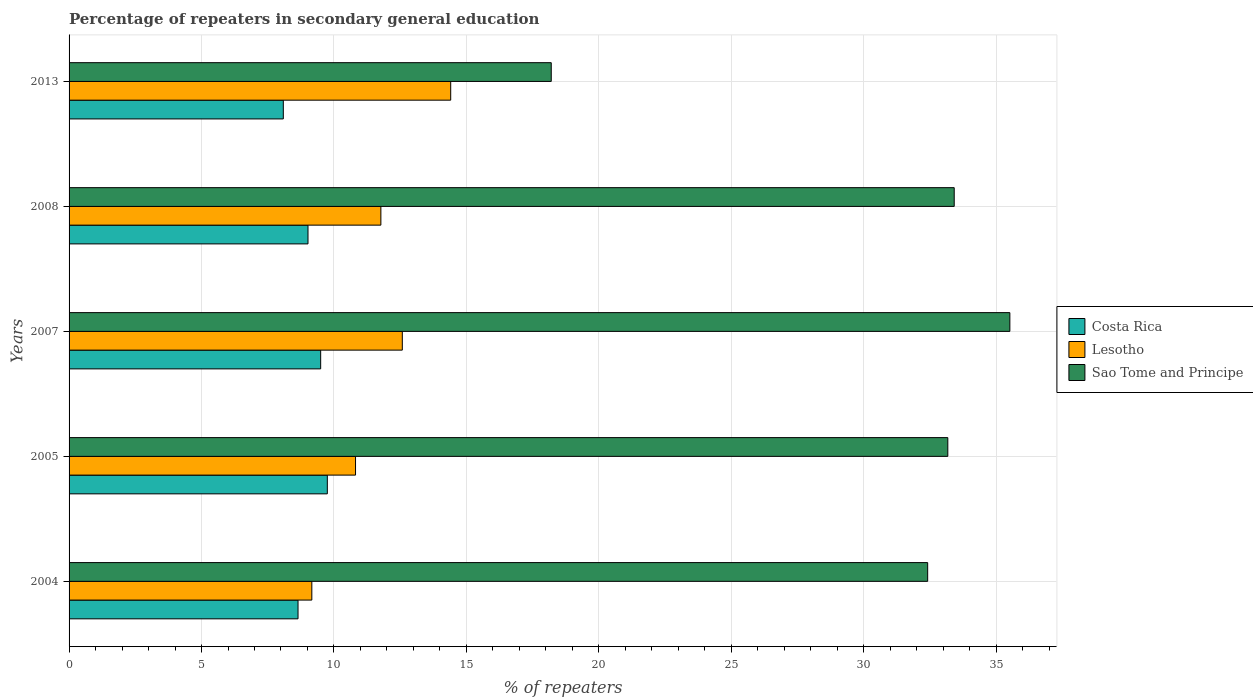How many different coloured bars are there?
Give a very brief answer. 3. How many bars are there on the 2nd tick from the top?
Your answer should be compact. 3. How many bars are there on the 2nd tick from the bottom?
Provide a short and direct response. 3. What is the percentage of repeaters in secondary general education in Costa Rica in 2004?
Offer a terse response. 8.64. Across all years, what is the maximum percentage of repeaters in secondary general education in Costa Rica?
Keep it short and to the point. 9.75. Across all years, what is the minimum percentage of repeaters in secondary general education in Costa Rica?
Make the answer very short. 8.09. In which year was the percentage of repeaters in secondary general education in Costa Rica minimum?
Ensure brevity in your answer.  2013. What is the total percentage of repeaters in secondary general education in Costa Rica in the graph?
Make the answer very short. 45. What is the difference between the percentage of repeaters in secondary general education in Sao Tome and Principe in 2005 and that in 2008?
Your answer should be compact. -0.24. What is the difference between the percentage of repeaters in secondary general education in Lesotho in 2013 and the percentage of repeaters in secondary general education in Sao Tome and Principe in 2007?
Your response must be concise. -21.11. What is the average percentage of repeaters in secondary general education in Sao Tome and Principe per year?
Keep it short and to the point. 30.55. In the year 2007, what is the difference between the percentage of repeaters in secondary general education in Sao Tome and Principe and percentage of repeaters in secondary general education in Costa Rica?
Offer a terse response. 26.02. In how many years, is the percentage of repeaters in secondary general education in Sao Tome and Principe greater than 16 %?
Provide a succinct answer. 5. What is the ratio of the percentage of repeaters in secondary general education in Sao Tome and Principe in 2004 to that in 2005?
Keep it short and to the point. 0.98. What is the difference between the highest and the second highest percentage of repeaters in secondary general education in Sao Tome and Principe?
Offer a terse response. 2.1. What is the difference between the highest and the lowest percentage of repeaters in secondary general education in Lesotho?
Your response must be concise. 5.24. What does the 1st bar from the top in 2013 represents?
Keep it short and to the point. Sao Tome and Principe. What does the 1st bar from the bottom in 2007 represents?
Keep it short and to the point. Costa Rica. Is it the case that in every year, the sum of the percentage of repeaters in secondary general education in Costa Rica and percentage of repeaters in secondary general education in Sao Tome and Principe is greater than the percentage of repeaters in secondary general education in Lesotho?
Ensure brevity in your answer.  Yes. Are all the bars in the graph horizontal?
Your answer should be compact. Yes. What is the difference between two consecutive major ticks on the X-axis?
Provide a short and direct response. 5. Are the values on the major ticks of X-axis written in scientific E-notation?
Offer a terse response. No. Does the graph contain grids?
Give a very brief answer. Yes. Where does the legend appear in the graph?
Your answer should be compact. Center right. How are the legend labels stacked?
Ensure brevity in your answer.  Vertical. What is the title of the graph?
Your answer should be very brief. Percentage of repeaters in secondary general education. Does "Djibouti" appear as one of the legend labels in the graph?
Offer a very short reply. No. What is the label or title of the X-axis?
Your answer should be compact. % of repeaters. What is the % of repeaters of Costa Rica in 2004?
Offer a terse response. 8.64. What is the % of repeaters in Lesotho in 2004?
Your answer should be compact. 9.16. What is the % of repeaters in Sao Tome and Principe in 2004?
Ensure brevity in your answer.  32.41. What is the % of repeaters of Costa Rica in 2005?
Offer a very short reply. 9.75. What is the % of repeaters of Lesotho in 2005?
Provide a short and direct response. 10.81. What is the % of repeaters of Sao Tome and Principe in 2005?
Provide a succinct answer. 33.18. What is the % of repeaters of Costa Rica in 2007?
Provide a short and direct response. 9.5. What is the % of repeaters in Lesotho in 2007?
Offer a terse response. 12.58. What is the % of repeaters of Sao Tome and Principe in 2007?
Make the answer very short. 35.52. What is the % of repeaters in Costa Rica in 2008?
Ensure brevity in your answer.  9.02. What is the % of repeaters in Lesotho in 2008?
Offer a very short reply. 11.77. What is the % of repeaters of Sao Tome and Principe in 2008?
Your answer should be very brief. 33.42. What is the % of repeaters in Costa Rica in 2013?
Provide a short and direct response. 8.09. What is the % of repeaters in Lesotho in 2013?
Give a very brief answer. 14.41. What is the % of repeaters of Sao Tome and Principe in 2013?
Provide a succinct answer. 18.2. Across all years, what is the maximum % of repeaters of Costa Rica?
Offer a very short reply. 9.75. Across all years, what is the maximum % of repeaters in Lesotho?
Ensure brevity in your answer.  14.41. Across all years, what is the maximum % of repeaters in Sao Tome and Principe?
Provide a succinct answer. 35.52. Across all years, what is the minimum % of repeaters in Costa Rica?
Provide a succinct answer. 8.09. Across all years, what is the minimum % of repeaters of Lesotho?
Ensure brevity in your answer.  9.16. Across all years, what is the minimum % of repeaters of Sao Tome and Principe?
Ensure brevity in your answer.  18.2. What is the total % of repeaters of Costa Rica in the graph?
Provide a succinct answer. 45. What is the total % of repeaters of Lesotho in the graph?
Your answer should be very brief. 58.74. What is the total % of repeaters of Sao Tome and Principe in the graph?
Your answer should be compact. 152.73. What is the difference between the % of repeaters of Costa Rica in 2004 and that in 2005?
Provide a succinct answer. -1.11. What is the difference between the % of repeaters in Lesotho in 2004 and that in 2005?
Make the answer very short. -1.65. What is the difference between the % of repeaters in Sao Tome and Principe in 2004 and that in 2005?
Your answer should be compact. -0.76. What is the difference between the % of repeaters of Costa Rica in 2004 and that in 2007?
Provide a short and direct response. -0.85. What is the difference between the % of repeaters of Lesotho in 2004 and that in 2007?
Offer a terse response. -3.42. What is the difference between the % of repeaters of Sao Tome and Principe in 2004 and that in 2007?
Your answer should be very brief. -3.1. What is the difference between the % of repeaters of Costa Rica in 2004 and that in 2008?
Your response must be concise. -0.38. What is the difference between the % of repeaters of Lesotho in 2004 and that in 2008?
Provide a short and direct response. -2.61. What is the difference between the % of repeaters in Sao Tome and Principe in 2004 and that in 2008?
Your response must be concise. -1. What is the difference between the % of repeaters of Costa Rica in 2004 and that in 2013?
Ensure brevity in your answer.  0.56. What is the difference between the % of repeaters of Lesotho in 2004 and that in 2013?
Your answer should be very brief. -5.24. What is the difference between the % of repeaters in Sao Tome and Principe in 2004 and that in 2013?
Your response must be concise. 14.21. What is the difference between the % of repeaters of Costa Rica in 2005 and that in 2007?
Give a very brief answer. 0.25. What is the difference between the % of repeaters of Lesotho in 2005 and that in 2007?
Ensure brevity in your answer.  -1.77. What is the difference between the % of repeaters of Sao Tome and Principe in 2005 and that in 2007?
Ensure brevity in your answer.  -2.34. What is the difference between the % of repeaters of Costa Rica in 2005 and that in 2008?
Your answer should be compact. 0.73. What is the difference between the % of repeaters of Lesotho in 2005 and that in 2008?
Your answer should be very brief. -0.96. What is the difference between the % of repeaters in Sao Tome and Principe in 2005 and that in 2008?
Provide a short and direct response. -0.24. What is the difference between the % of repeaters of Costa Rica in 2005 and that in 2013?
Make the answer very short. 1.66. What is the difference between the % of repeaters of Lesotho in 2005 and that in 2013?
Make the answer very short. -3.59. What is the difference between the % of repeaters of Sao Tome and Principe in 2005 and that in 2013?
Provide a short and direct response. 14.97. What is the difference between the % of repeaters in Costa Rica in 2007 and that in 2008?
Make the answer very short. 0.48. What is the difference between the % of repeaters in Lesotho in 2007 and that in 2008?
Make the answer very short. 0.81. What is the difference between the % of repeaters of Sao Tome and Principe in 2007 and that in 2008?
Provide a short and direct response. 2.1. What is the difference between the % of repeaters in Costa Rica in 2007 and that in 2013?
Make the answer very short. 1.41. What is the difference between the % of repeaters of Lesotho in 2007 and that in 2013?
Keep it short and to the point. -1.83. What is the difference between the % of repeaters of Sao Tome and Principe in 2007 and that in 2013?
Your answer should be compact. 17.31. What is the difference between the % of repeaters in Costa Rica in 2008 and that in 2013?
Offer a terse response. 0.93. What is the difference between the % of repeaters in Lesotho in 2008 and that in 2013?
Make the answer very short. -2.64. What is the difference between the % of repeaters in Sao Tome and Principe in 2008 and that in 2013?
Ensure brevity in your answer.  15.21. What is the difference between the % of repeaters in Costa Rica in 2004 and the % of repeaters in Lesotho in 2005?
Offer a terse response. -2.17. What is the difference between the % of repeaters in Costa Rica in 2004 and the % of repeaters in Sao Tome and Principe in 2005?
Ensure brevity in your answer.  -24.53. What is the difference between the % of repeaters in Lesotho in 2004 and the % of repeaters in Sao Tome and Principe in 2005?
Offer a terse response. -24.01. What is the difference between the % of repeaters in Costa Rica in 2004 and the % of repeaters in Lesotho in 2007?
Your answer should be very brief. -3.94. What is the difference between the % of repeaters in Costa Rica in 2004 and the % of repeaters in Sao Tome and Principe in 2007?
Your answer should be very brief. -26.87. What is the difference between the % of repeaters in Lesotho in 2004 and the % of repeaters in Sao Tome and Principe in 2007?
Provide a succinct answer. -26.35. What is the difference between the % of repeaters of Costa Rica in 2004 and the % of repeaters of Lesotho in 2008?
Your answer should be compact. -3.13. What is the difference between the % of repeaters of Costa Rica in 2004 and the % of repeaters of Sao Tome and Principe in 2008?
Offer a terse response. -24.77. What is the difference between the % of repeaters in Lesotho in 2004 and the % of repeaters in Sao Tome and Principe in 2008?
Give a very brief answer. -24.25. What is the difference between the % of repeaters in Costa Rica in 2004 and the % of repeaters in Lesotho in 2013?
Keep it short and to the point. -5.76. What is the difference between the % of repeaters in Costa Rica in 2004 and the % of repeaters in Sao Tome and Principe in 2013?
Keep it short and to the point. -9.56. What is the difference between the % of repeaters in Lesotho in 2004 and the % of repeaters in Sao Tome and Principe in 2013?
Give a very brief answer. -9.04. What is the difference between the % of repeaters of Costa Rica in 2005 and the % of repeaters of Lesotho in 2007?
Offer a terse response. -2.83. What is the difference between the % of repeaters of Costa Rica in 2005 and the % of repeaters of Sao Tome and Principe in 2007?
Make the answer very short. -25.77. What is the difference between the % of repeaters in Lesotho in 2005 and the % of repeaters in Sao Tome and Principe in 2007?
Give a very brief answer. -24.7. What is the difference between the % of repeaters of Costa Rica in 2005 and the % of repeaters of Lesotho in 2008?
Ensure brevity in your answer.  -2.02. What is the difference between the % of repeaters in Costa Rica in 2005 and the % of repeaters in Sao Tome and Principe in 2008?
Make the answer very short. -23.67. What is the difference between the % of repeaters of Lesotho in 2005 and the % of repeaters of Sao Tome and Principe in 2008?
Keep it short and to the point. -22.6. What is the difference between the % of repeaters in Costa Rica in 2005 and the % of repeaters in Lesotho in 2013?
Provide a succinct answer. -4.66. What is the difference between the % of repeaters in Costa Rica in 2005 and the % of repeaters in Sao Tome and Principe in 2013?
Provide a succinct answer. -8.45. What is the difference between the % of repeaters of Lesotho in 2005 and the % of repeaters of Sao Tome and Principe in 2013?
Provide a succinct answer. -7.39. What is the difference between the % of repeaters in Costa Rica in 2007 and the % of repeaters in Lesotho in 2008?
Provide a short and direct response. -2.27. What is the difference between the % of repeaters in Costa Rica in 2007 and the % of repeaters in Sao Tome and Principe in 2008?
Your response must be concise. -23.92. What is the difference between the % of repeaters in Lesotho in 2007 and the % of repeaters in Sao Tome and Principe in 2008?
Make the answer very short. -20.84. What is the difference between the % of repeaters of Costa Rica in 2007 and the % of repeaters of Lesotho in 2013?
Keep it short and to the point. -4.91. What is the difference between the % of repeaters in Costa Rica in 2007 and the % of repeaters in Sao Tome and Principe in 2013?
Make the answer very short. -8.7. What is the difference between the % of repeaters in Lesotho in 2007 and the % of repeaters in Sao Tome and Principe in 2013?
Offer a very short reply. -5.62. What is the difference between the % of repeaters in Costa Rica in 2008 and the % of repeaters in Lesotho in 2013?
Give a very brief answer. -5.39. What is the difference between the % of repeaters of Costa Rica in 2008 and the % of repeaters of Sao Tome and Principe in 2013?
Ensure brevity in your answer.  -9.18. What is the difference between the % of repeaters in Lesotho in 2008 and the % of repeaters in Sao Tome and Principe in 2013?
Provide a succinct answer. -6.43. What is the average % of repeaters in Costa Rica per year?
Your answer should be compact. 9. What is the average % of repeaters of Lesotho per year?
Your response must be concise. 11.75. What is the average % of repeaters in Sao Tome and Principe per year?
Your answer should be very brief. 30.55. In the year 2004, what is the difference between the % of repeaters of Costa Rica and % of repeaters of Lesotho?
Give a very brief answer. -0.52. In the year 2004, what is the difference between the % of repeaters in Costa Rica and % of repeaters in Sao Tome and Principe?
Offer a very short reply. -23.77. In the year 2004, what is the difference between the % of repeaters of Lesotho and % of repeaters of Sao Tome and Principe?
Ensure brevity in your answer.  -23.25. In the year 2005, what is the difference between the % of repeaters of Costa Rica and % of repeaters of Lesotho?
Your answer should be compact. -1.06. In the year 2005, what is the difference between the % of repeaters of Costa Rica and % of repeaters of Sao Tome and Principe?
Your answer should be very brief. -23.43. In the year 2005, what is the difference between the % of repeaters of Lesotho and % of repeaters of Sao Tome and Principe?
Give a very brief answer. -22.36. In the year 2007, what is the difference between the % of repeaters of Costa Rica and % of repeaters of Lesotho?
Offer a very short reply. -3.08. In the year 2007, what is the difference between the % of repeaters in Costa Rica and % of repeaters in Sao Tome and Principe?
Your answer should be very brief. -26.02. In the year 2007, what is the difference between the % of repeaters of Lesotho and % of repeaters of Sao Tome and Principe?
Offer a terse response. -22.94. In the year 2008, what is the difference between the % of repeaters in Costa Rica and % of repeaters in Lesotho?
Keep it short and to the point. -2.75. In the year 2008, what is the difference between the % of repeaters of Costa Rica and % of repeaters of Sao Tome and Principe?
Your answer should be compact. -24.4. In the year 2008, what is the difference between the % of repeaters of Lesotho and % of repeaters of Sao Tome and Principe?
Your answer should be very brief. -21.65. In the year 2013, what is the difference between the % of repeaters in Costa Rica and % of repeaters in Lesotho?
Offer a terse response. -6.32. In the year 2013, what is the difference between the % of repeaters of Costa Rica and % of repeaters of Sao Tome and Principe?
Your answer should be compact. -10.12. In the year 2013, what is the difference between the % of repeaters of Lesotho and % of repeaters of Sao Tome and Principe?
Offer a very short reply. -3.8. What is the ratio of the % of repeaters of Costa Rica in 2004 to that in 2005?
Give a very brief answer. 0.89. What is the ratio of the % of repeaters in Lesotho in 2004 to that in 2005?
Your answer should be very brief. 0.85. What is the ratio of the % of repeaters of Sao Tome and Principe in 2004 to that in 2005?
Provide a short and direct response. 0.98. What is the ratio of the % of repeaters of Costa Rica in 2004 to that in 2007?
Make the answer very short. 0.91. What is the ratio of the % of repeaters in Lesotho in 2004 to that in 2007?
Make the answer very short. 0.73. What is the ratio of the % of repeaters of Sao Tome and Principe in 2004 to that in 2007?
Keep it short and to the point. 0.91. What is the ratio of the % of repeaters in Lesotho in 2004 to that in 2008?
Your response must be concise. 0.78. What is the ratio of the % of repeaters in Sao Tome and Principe in 2004 to that in 2008?
Your answer should be very brief. 0.97. What is the ratio of the % of repeaters of Costa Rica in 2004 to that in 2013?
Your response must be concise. 1.07. What is the ratio of the % of repeaters in Lesotho in 2004 to that in 2013?
Offer a terse response. 0.64. What is the ratio of the % of repeaters of Sao Tome and Principe in 2004 to that in 2013?
Ensure brevity in your answer.  1.78. What is the ratio of the % of repeaters in Costa Rica in 2005 to that in 2007?
Your response must be concise. 1.03. What is the ratio of the % of repeaters in Lesotho in 2005 to that in 2007?
Provide a succinct answer. 0.86. What is the ratio of the % of repeaters of Sao Tome and Principe in 2005 to that in 2007?
Your answer should be very brief. 0.93. What is the ratio of the % of repeaters of Costa Rica in 2005 to that in 2008?
Ensure brevity in your answer.  1.08. What is the ratio of the % of repeaters of Lesotho in 2005 to that in 2008?
Your answer should be compact. 0.92. What is the ratio of the % of repeaters in Sao Tome and Principe in 2005 to that in 2008?
Give a very brief answer. 0.99. What is the ratio of the % of repeaters in Costa Rica in 2005 to that in 2013?
Provide a short and direct response. 1.21. What is the ratio of the % of repeaters of Lesotho in 2005 to that in 2013?
Offer a terse response. 0.75. What is the ratio of the % of repeaters of Sao Tome and Principe in 2005 to that in 2013?
Offer a terse response. 1.82. What is the ratio of the % of repeaters of Costa Rica in 2007 to that in 2008?
Ensure brevity in your answer.  1.05. What is the ratio of the % of repeaters of Lesotho in 2007 to that in 2008?
Your answer should be compact. 1.07. What is the ratio of the % of repeaters in Sao Tome and Principe in 2007 to that in 2008?
Provide a short and direct response. 1.06. What is the ratio of the % of repeaters of Costa Rica in 2007 to that in 2013?
Your response must be concise. 1.17. What is the ratio of the % of repeaters of Lesotho in 2007 to that in 2013?
Keep it short and to the point. 0.87. What is the ratio of the % of repeaters of Sao Tome and Principe in 2007 to that in 2013?
Offer a terse response. 1.95. What is the ratio of the % of repeaters in Costa Rica in 2008 to that in 2013?
Your answer should be very brief. 1.12. What is the ratio of the % of repeaters in Lesotho in 2008 to that in 2013?
Your answer should be very brief. 0.82. What is the ratio of the % of repeaters of Sao Tome and Principe in 2008 to that in 2013?
Keep it short and to the point. 1.84. What is the difference between the highest and the second highest % of repeaters in Costa Rica?
Provide a short and direct response. 0.25. What is the difference between the highest and the second highest % of repeaters of Lesotho?
Make the answer very short. 1.83. What is the difference between the highest and the second highest % of repeaters in Sao Tome and Principe?
Make the answer very short. 2.1. What is the difference between the highest and the lowest % of repeaters in Costa Rica?
Keep it short and to the point. 1.66. What is the difference between the highest and the lowest % of repeaters in Lesotho?
Make the answer very short. 5.24. What is the difference between the highest and the lowest % of repeaters in Sao Tome and Principe?
Your response must be concise. 17.31. 